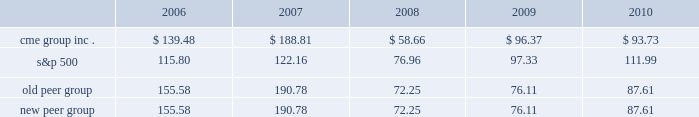Performance graph the following graph compares the cumulative five-year total return provided shareholders on our class a common stock relative to the cumulative total returns of the s&p 500 index and two customized peer groups .
The old peer group includes intercontinentalexchange , inc. , nyse euronext and the nasdaq omx group inc .
The new peer group is the same as the old peer group with the addition of cboe holdings , inc .
Which completed its initial public offering in june 2010 .
An investment of $ 100 ( with reinvestment of all dividends ) is assumed to have been made in our class a common stock , in the peer groups and the s&p 500 index on december 31 , 2005 and its relative performance is tracked through december 31 , 2010 .
Comparison of 5 year cumulative total return* among cme group inc. , the s&p 500 index , an old peer group and a new peer group 12/05 12/06 12/07 12/08 12/09 12/10 cme group inc .
S&p 500 old peer group *$ 100 invested on 12/31/05 in stock or index , including reinvestment of dividends .
Fiscal year ending december 31 .
Copyright a9 2011 s&p , a division of the mcgraw-hill companies inc .
All rights reserved .
New peer group the stock price performance included in this graph is not necessarily indicative of future stock price performance .

What was the percentual return for s&p 500 in the first year? 
Rationale: its the percentage of the difference between the initial $ 100 and the final $ 115
Computations: (115.80 - 100)
Answer: 15.8. 